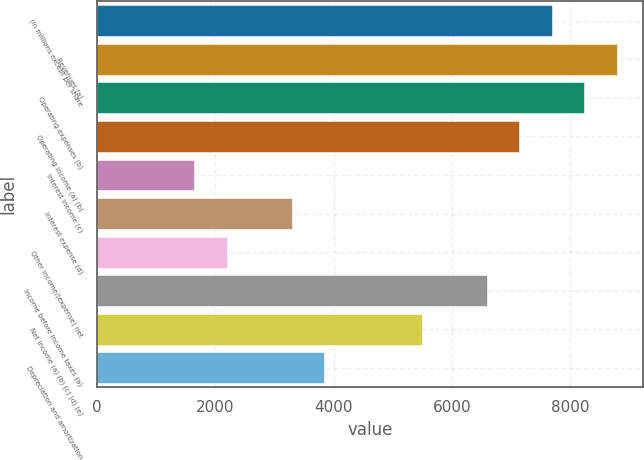Convert chart to OTSL. <chart><loc_0><loc_0><loc_500><loc_500><bar_chart><fcel>(in millions except per share<fcel>Revenues (a)<fcel>Operating expenses (b)<fcel>Operating income (a) (b)<fcel>Interest income (c)<fcel>Interest expense (d)<fcel>Other income/(expense) net<fcel>Income before income taxes (a)<fcel>Net income (a) (b) (c) (d) (e)<fcel>Depreciation and amortization<nl><fcel>7687.85<fcel>8786.07<fcel>8236.96<fcel>7138.74<fcel>1647.64<fcel>3294.97<fcel>2196.75<fcel>6589.63<fcel>5491.41<fcel>3844.08<nl></chart> 